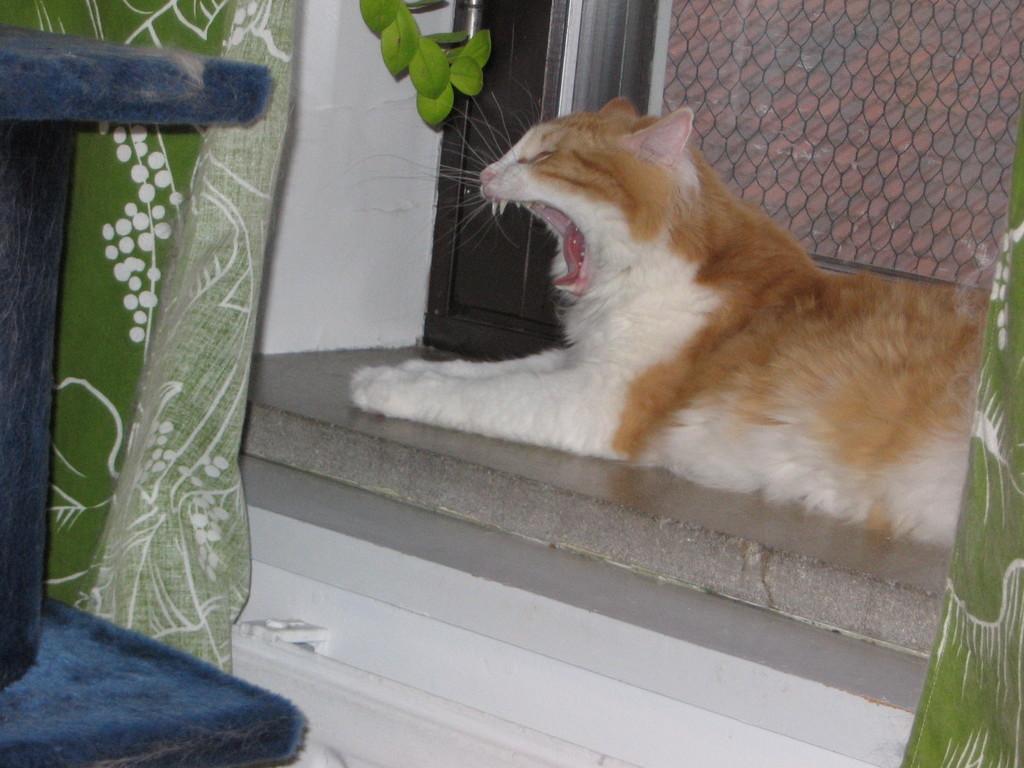How would you summarize this image in a sentence or two? In this image in the center there is one cat and in the background there is a door, net and on the left side there is one blanket and chair. At the bottom there is floor. 